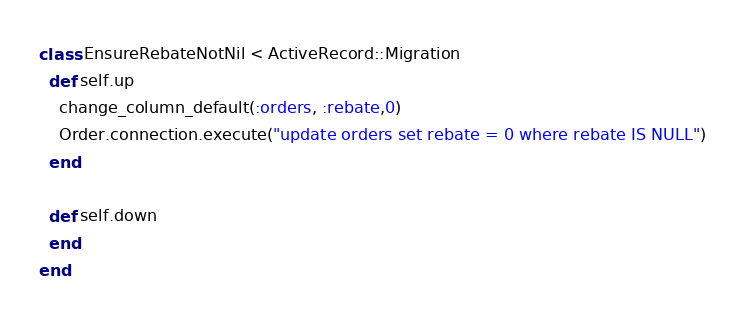Convert code to text. <code><loc_0><loc_0><loc_500><loc_500><_Ruby_>class EnsureRebateNotNil < ActiveRecord::Migration
  def self.up
    change_column_default(:orders, :rebate,0)
    Order.connection.execute("update orders set rebate = 0 where rebate IS NULL")
  end

  def self.down
  end
end
</code> 